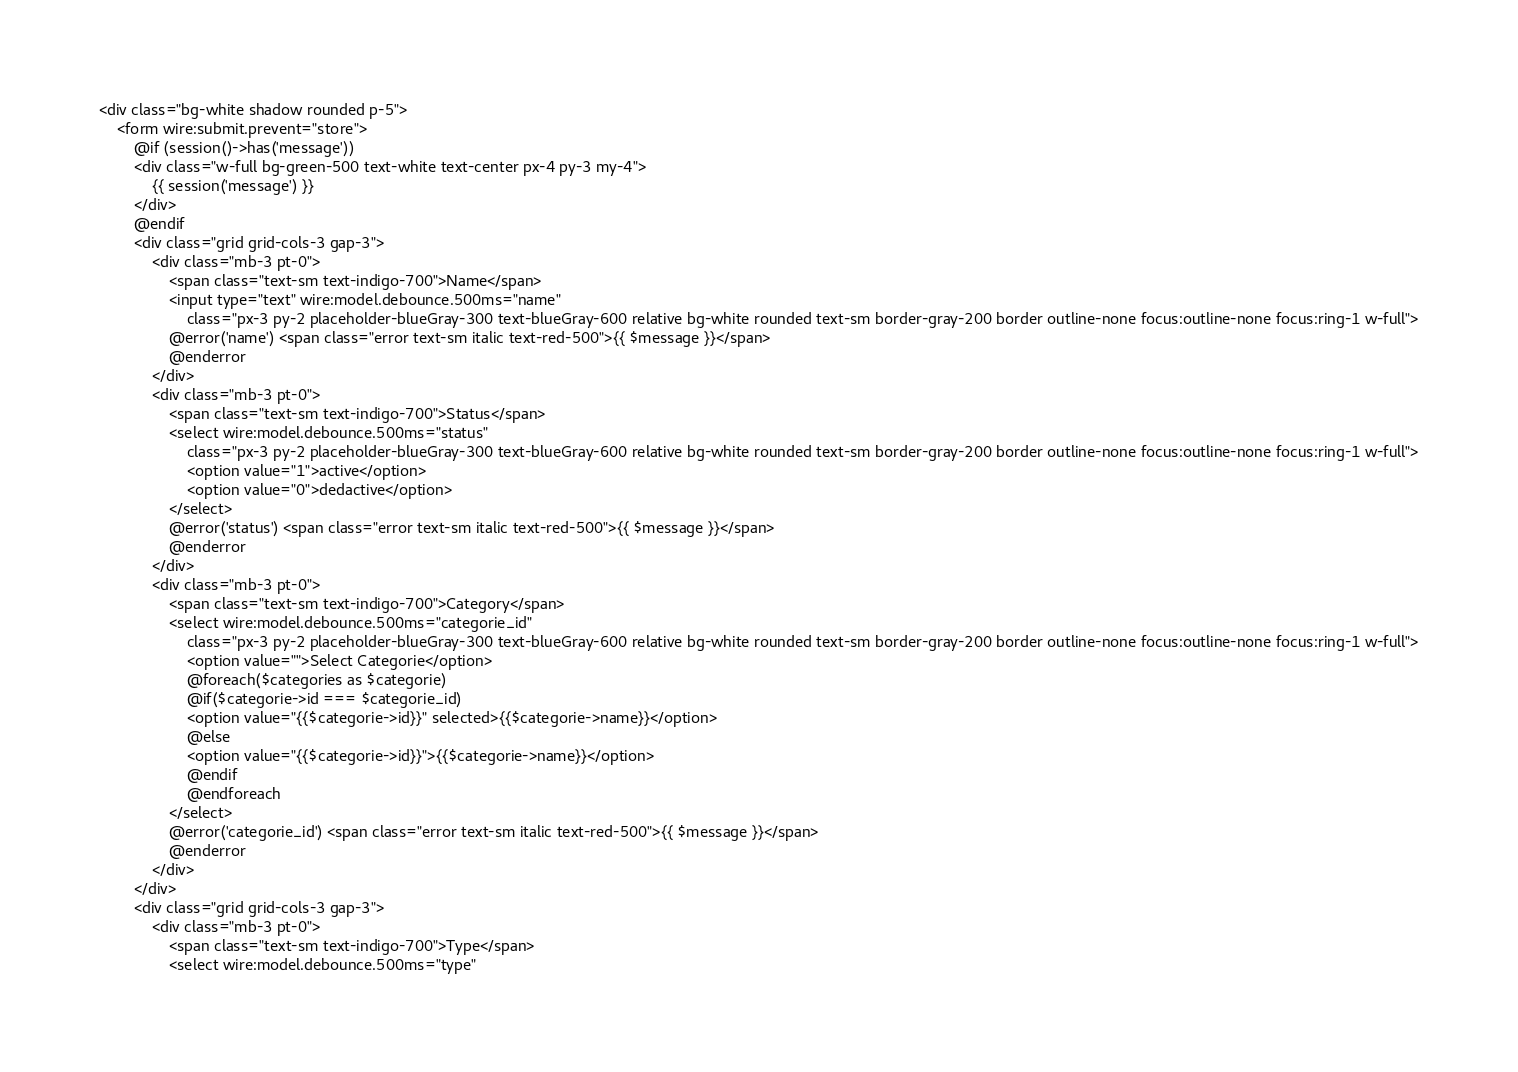Convert code to text. <code><loc_0><loc_0><loc_500><loc_500><_PHP_><div class="bg-white shadow rounded p-5">
    <form wire:submit.prevent="store">
        @if (session()->has('message'))
        <div class="w-full bg-green-500 text-white text-center px-4 py-3 my-4">
            {{ session('message') }}
        </div>
        @endif
        <div class="grid grid-cols-3 gap-3">
            <div class="mb-3 pt-0">
                <span class="text-sm text-indigo-700">Name</span>
                <input type="text" wire:model.debounce.500ms="name"
                    class="px-3 py-2 placeholder-blueGray-300 text-blueGray-600 relative bg-white rounded text-sm border-gray-200 border outline-none focus:outline-none focus:ring-1 w-full">
                @error('name') <span class="error text-sm italic text-red-500">{{ $message }}</span>
                @enderror
            </div>
            <div class="mb-3 pt-0">
                <span class="text-sm text-indigo-700">Status</span>
                <select wire:model.debounce.500ms="status"
                    class="px-3 py-2 placeholder-blueGray-300 text-blueGray-600 relative bg-white rounded text-sm border-gray-200 border outline-none focus:outline-none focus:ring-1 w-full">
                    <option value="1">active</option>
                    <option value="0">dedactive</option>
                </select>
                @error('status') <span class="error text-sm italic text-red-500">{{ $message }}</span>
                @enderror
            </div>
            <div class="mb-3 pt-0">
                <span class="text-sm text-indigo-700">Category</span>
                <select wire:model.debounce.500ms="categorie_id"
                    class="px-3 py-2 placeholder-blueGray-300 text-blueGray-600 relative bg-white rounded text-sm border-gray-200 border outline-none focus:outline-none focus:ring-1 w-full">
                    <option value="">Select Categorie</option>
                    @foreach($categories as $categorie)
                    @if($categorie->id === $categorie_id)
                    <option value="{{$categorie->id}}" selected>{{$categorie->name}}</option>
                    @else
                    <option value="{{$categorie->id}}">{{$categorie->name}}</option>
                    @endif
                    @endforeach
                </select>
                @error('categorie_id') <span class="error text-sm italic text-red-500">{{ $message }}</span>
                @enderror
            </div>
        </div>
        <div class="grid grid-cols-3 gap-3">
            <div class="mb-3 pt-0">
                <span class="text-sm text-indigo-700">Type</span>
                <select wire:model.debounce.500ms="type"</code> 